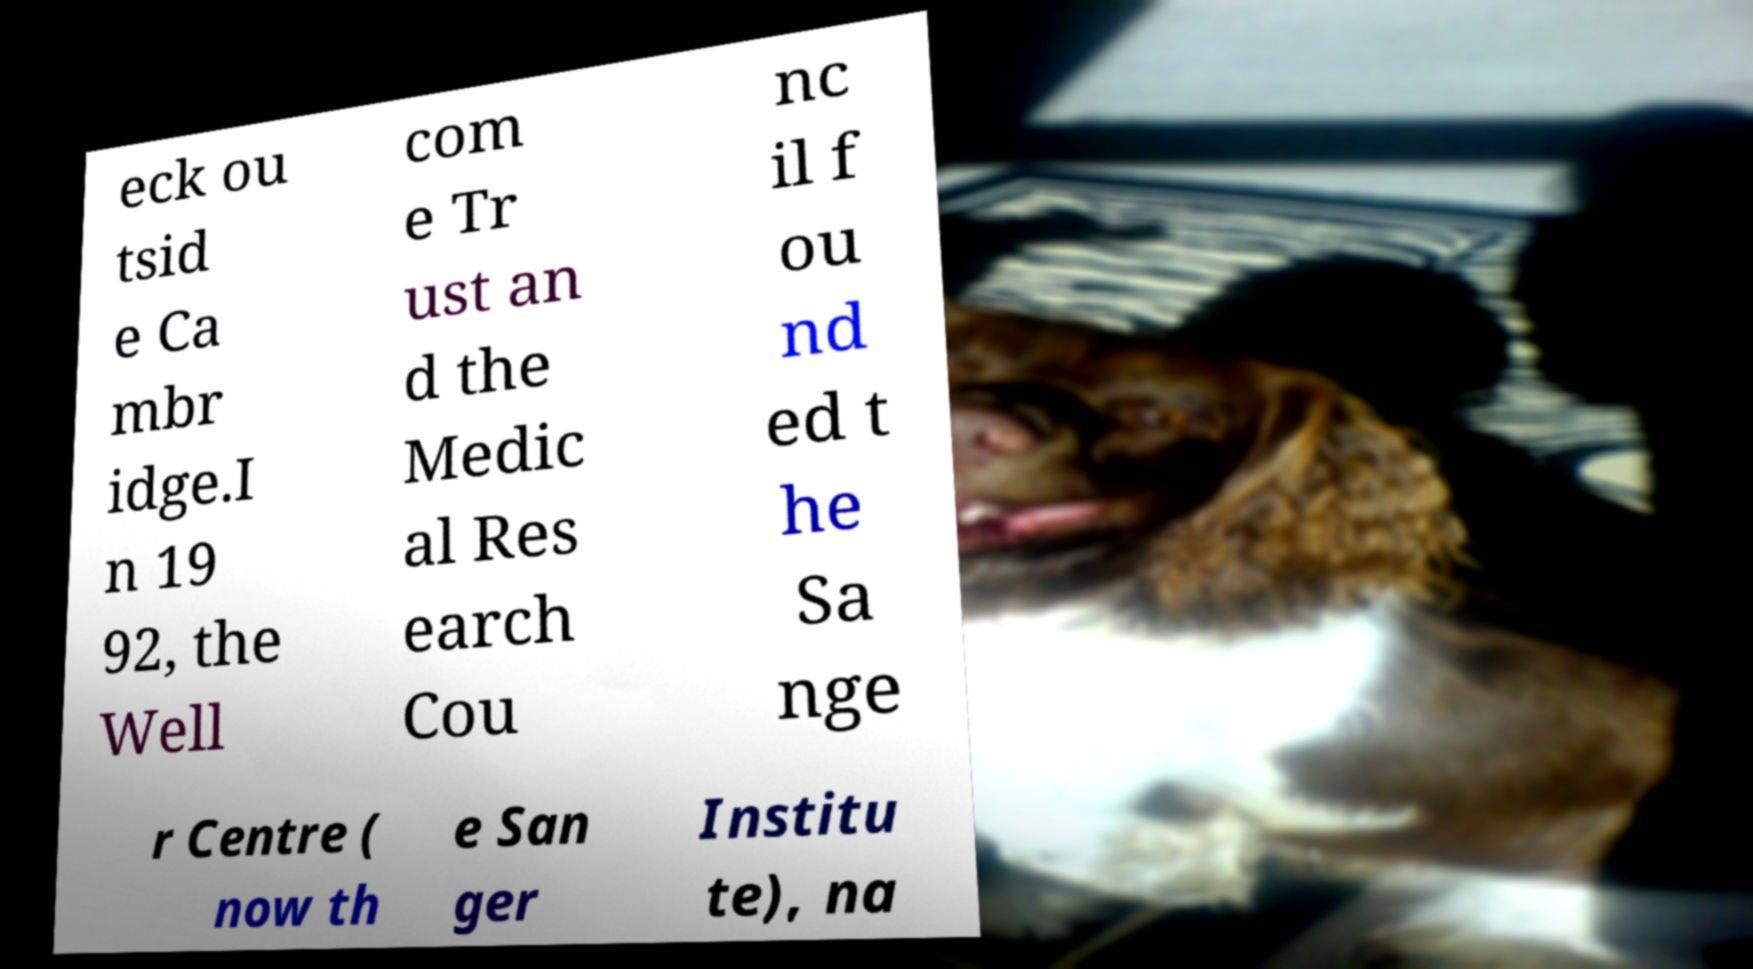I need the written content from this picture converted into text. Can you do that? eck ou tsid e Ca mbr idge.I n 19 92, the Well com e Tr ust an d the Medic al Res earch Cou nc il f ou nd ed t he Sa nge r Centre ( now th e San ger Institu te), na 